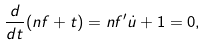Convert formula to latex. <formula><loc_0><loc_0><loc_500><loc_500>\frac { d } { d t } ( n f + t ) = n f ^ { \prime } \dot { u } + 1 = 0 ,</formula> 